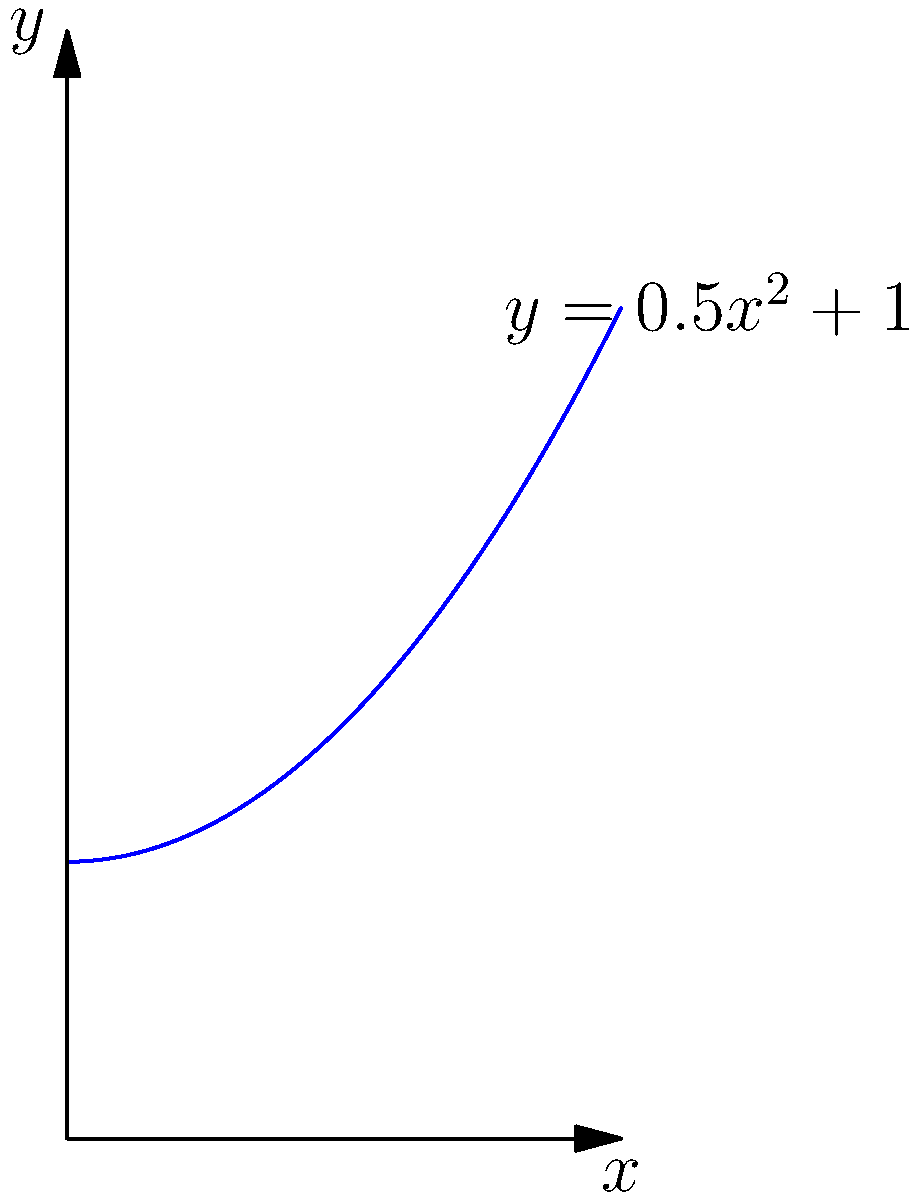A balalaika-inspired curve is represented by the function $f(x) = 0.5x^2 + 1$ on the interval $[0, 2]$. If this curve is rotated around the y-axis, what is the volume of the resulting solid? Round your answer to two decimal places. To find the volume of the solid formed by rotating the curve around the y-axis, we'll use the washer method:

1) The volume is given by the formula: $V = \pi \int_a^b [R(y)^2 - r(y)^2] dy$

2) We need to express x in terms of y:
   $y = 0.5x^2 + 1$
   $y - 1 = 0.5x^2$
   $x^2 = 2(y-1)$
   $x = \sqrt{2(y-1)}$

3) The outer radius R(y) is x: $R(y) = \sqrt{2(y-1)}$
   The inner radius r(y) is 0 (rotation around y-axis)

4) The limits of integration:
   When $x = 0$, $y = 1$
   When $x = 2$, $y = 0.5(2)^2 + 1 = 3$

5) Substituting into the volume formula:
   $V = \pi \int_1^3 [\sqrt{2(y-1)}^2 - 0^2] dy$
   $V = \pi \int_1^3 2(y-1) dy$

6) Integrating:
   $V = \pi [y^2 - 2y]_1^3$
   $V = \pi [(3^2 - 2(3)) - (1^2 - 2(1))]$
   $V = \pi [9 - 6 - 1 + 2]$
   $V = 4\pi$

7) Rounding to two decimal places:
   $V \approx 12.57$
Answer: $12.57$ cubic units 